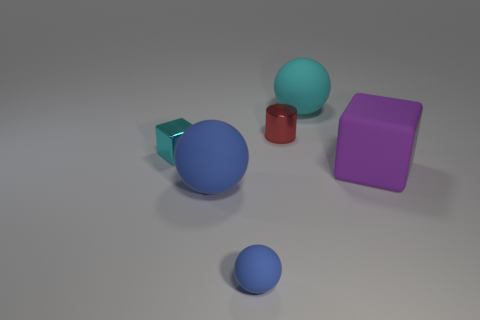What is the color of the small ball?
Your response must be concise. Blue. The large object left of the large sphere behind the big ball in front of the purple thing is made of what material?
Offer a terse response. Rubber. What size is the cyan thing that is made of the same material as the purple block?
Offer a terse response. Large. Is there a metal cylinder of the same color as the small sphere?
Offer a terse response. No. Does the shiny cylinder have the same size as the cyan object that is to the right of the tiny metallic cylinder?
Provide a succinct answer. No. What number of cubes are behind the metal object on the left side of the small metal thing behind the metallic cube?
Make the answer very short. 0. Are there any small things to the right of the cyan cube?
Your answer should be very brief. Yes. The tiny cyan object has what shape?
Give a very brief answer. Cube. What is the shape of the blue matte object in front of the large sphere that is in front of the tiny object that is left of the small blue object?
Your answer should be compact. Sphere. How many other things are there of the same shape as the tiny matte object?
Offer a very short reply. 2. 